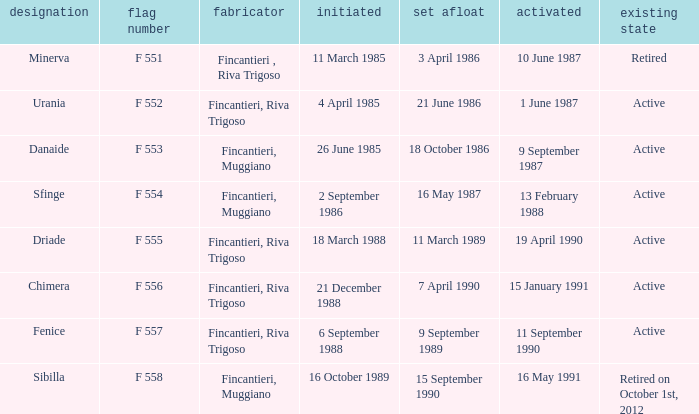What is the name of the builder who launched in danaide 18 October 1986. 